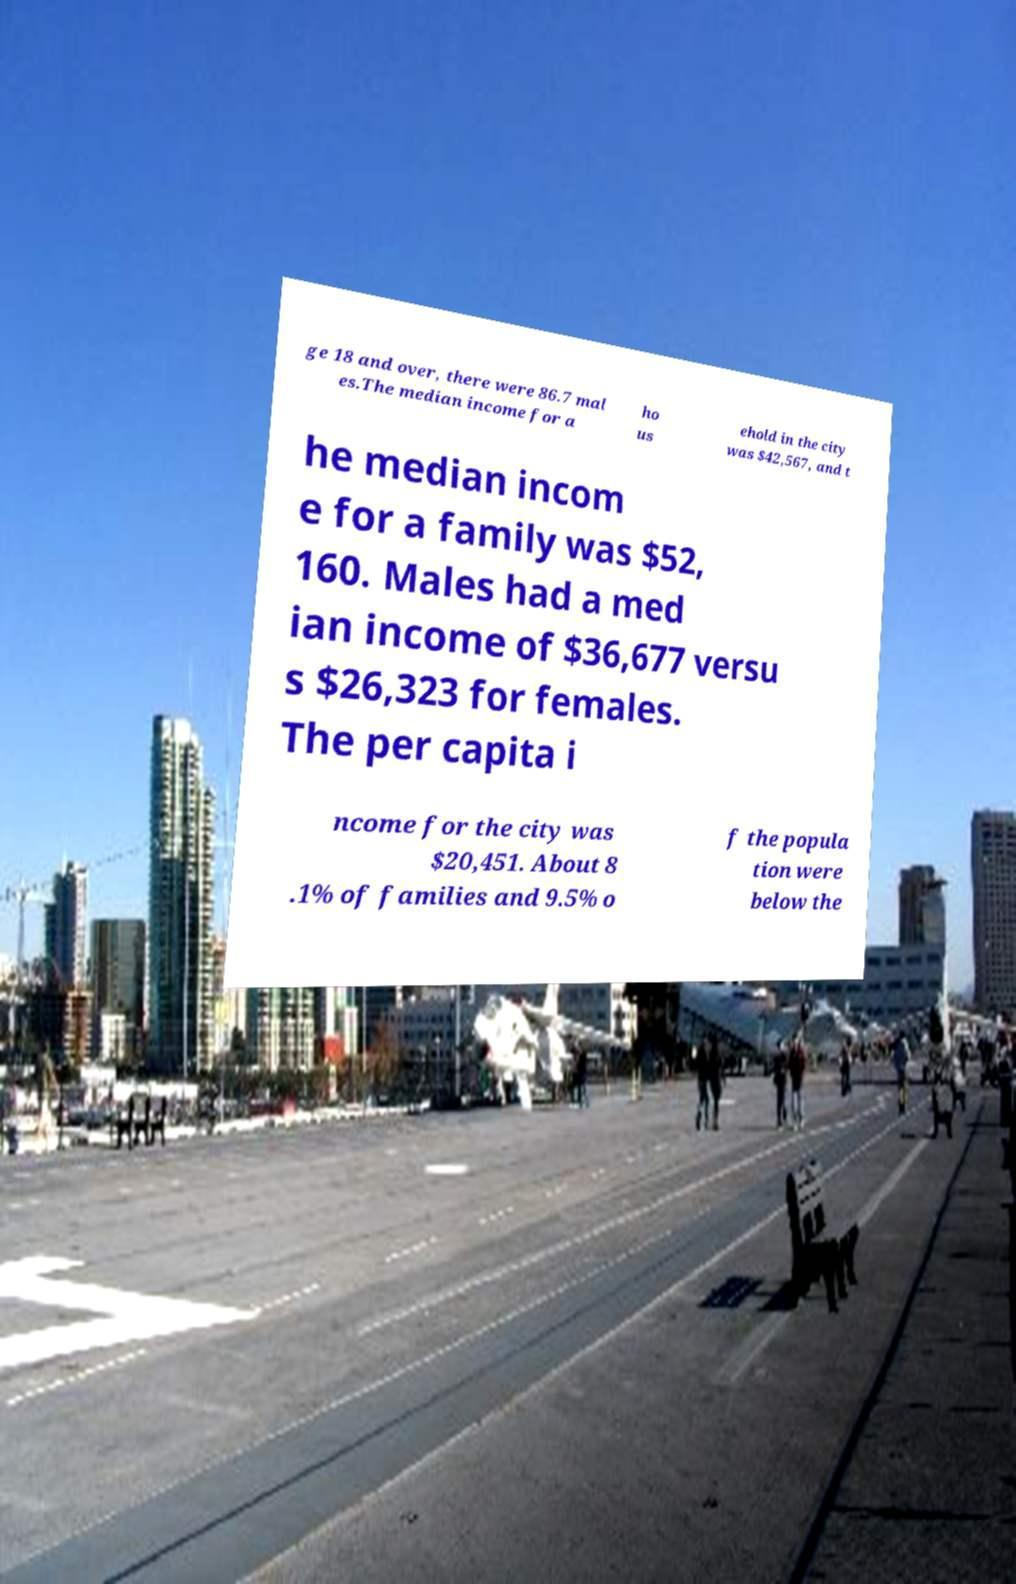Please identify and transcribe the text found in this image. ge 18 and over, there were 86.7 mal es.The median income for a ho us ehold in the city was $42,567, and t he median incom e for a family was $52, 160. Males had a med ian income of $36,677 versu s $26,323 for females. The per capita i ncome for the city was $20,451. About 8 .1% of families and 9.5% o f the popula tion were below the 